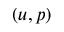Convert formula to latex. <formula><loc_0><loc_0><loc_500><loc_500>( u , p )</formula> 